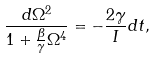Convert formula to latex. <formula><loc_0><loc_0><loc_500><loc_500>\frac { d \Omega ^ { 2 } } { 1 + \frac { \beta } { \gamma } \Omega ^ { 4 } } = - \frac { 2 \gamma } { I } d t ,</formula> 